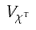<formula> <loc_0><loc_0><loc_500><loc_500>V _ { \chi ^ { \tau } }</formula> 